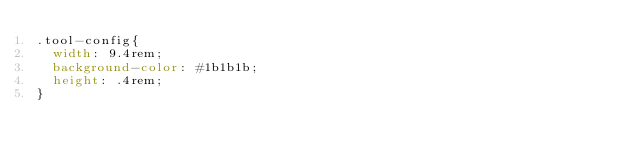<code> <loc_0><loc_0><loc_500><loc_500><_CSS_>.tool-config{
  width: 9.4rem;
  background-color: #1b1b1b;
  height: .4rem;
}</code> 